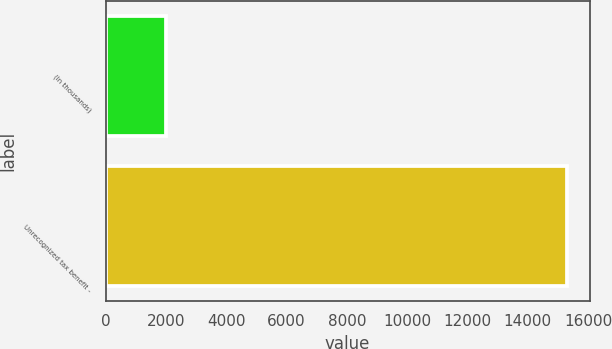Convert chart. <chart><loc_0><loc_0><loc_500><loc_500><bar_chart><fcel>(In thousands)<fcel>Unrecognized tax benefit -<nl><fcel>2017<fcel>15287<nl></chart> 